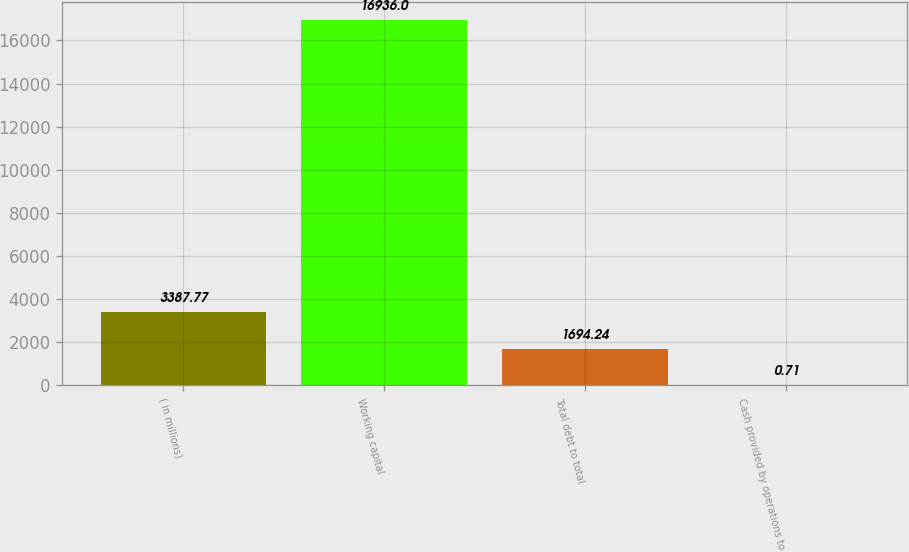<chart> <loc_0><loc_0><loc_500><loc_500><bar_chart><fcel>( in millions)<fcel>Working capital<fcel>Total debt to total<fcel>Cash provided by operations to<nl><fcel>3387.77<fcel>16936<fcel>1694.24<fcel>0.71<nl></chart> 